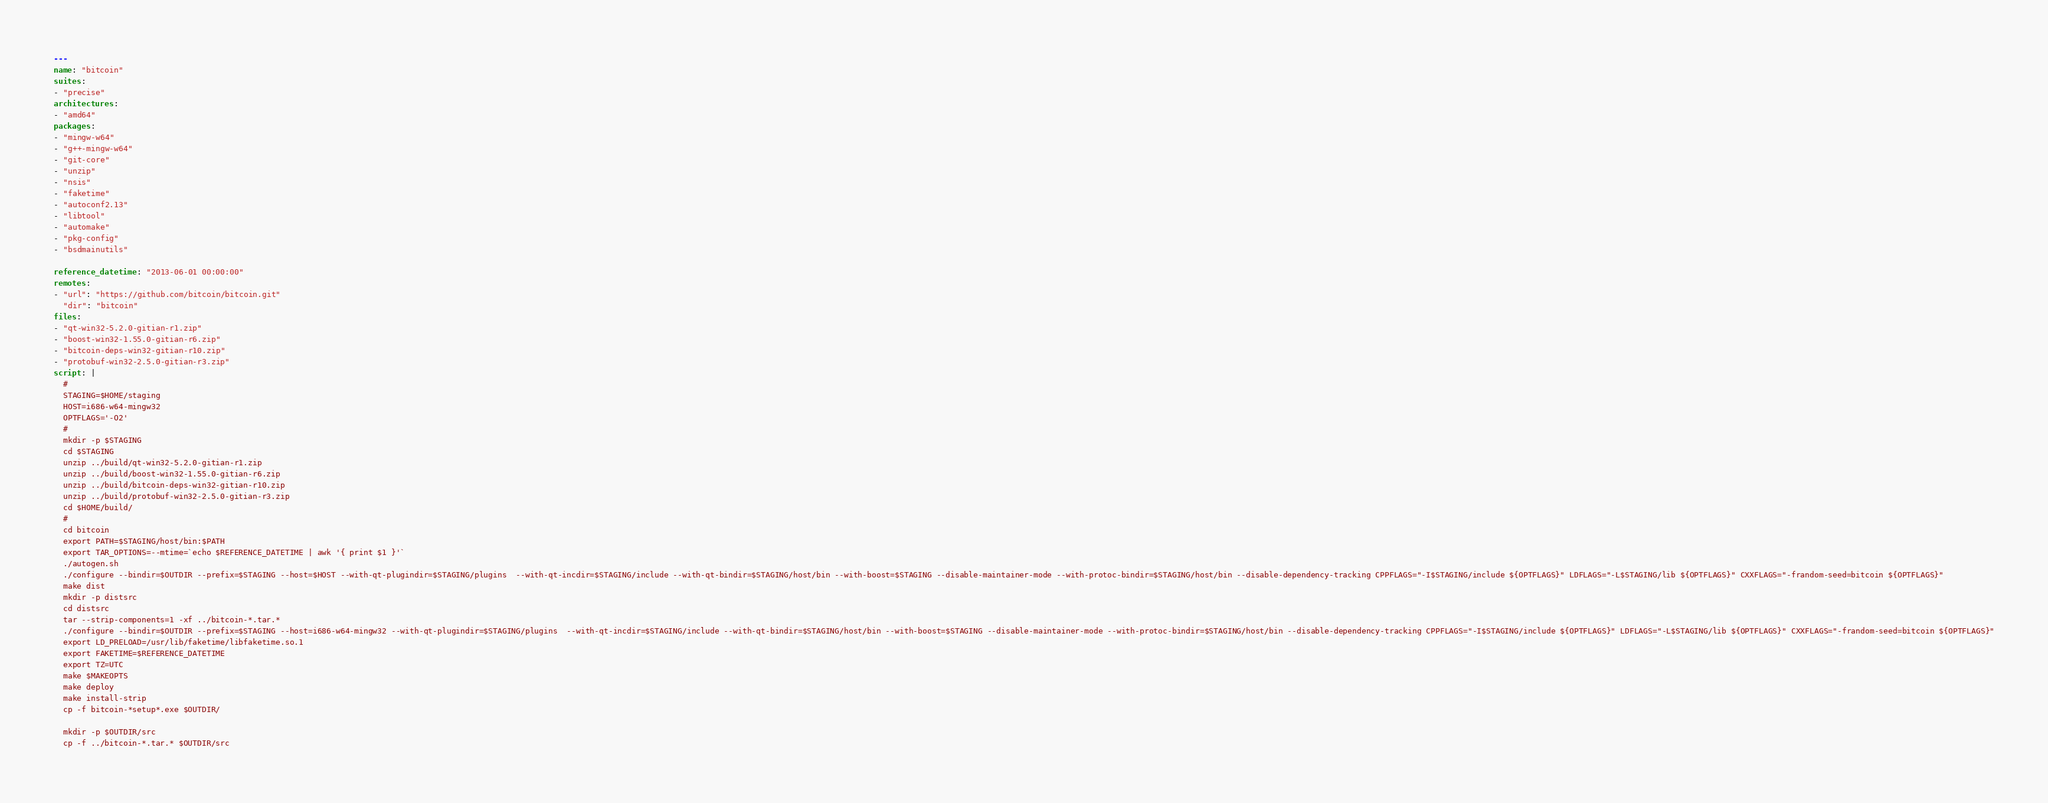Convert code to text. <code><loc_0><loc_0><loc_500><loc_500><_YAML_>---
name: "bitcoin"
suites:
- "precise"
architectures:
- "amd64"
packages:
- "mingw-w64"
- "g++-mingw-w64"
- "git-core"
- "unzip"
- "nsis"
- "faketime"
- "autoconf2.13"
- "libtool"
- "automake"
- "pkg-config"
- "bsdmainutils"

reference_datetime: "2013-06-01 00:00:00"
remotes:
- "url": "https://github.com/bitcoin/bitcoin.git"
  "dir": "bitcoin"
files:
- "qt-win32-5.2.0-gitian-r1.zip"
- "boost-win32-1.55.0-gitian-r6.zip"
- "bitcoin-deps-win32-gitian-r10.zip"
- "protobuf-win32-2.5.0-gitian-r3.zip"
script: |
  #
  STAGING=$HOME/staging
  HOST=i686-w64-mingw32
  OPTFLAGS='-O2'
  #
  mkdir -p $STAGING
  cd $STAGING
  unzip ../build/qt-win32-5.2.0-gitian-r1.zip
  unzip ../build/boost-win32-1.55.0-gitian-r6.zip
  unzip ../build/bitcoin-deps-win32-gitian-r10.zip
  unzip ../build/protobuf-win32-2.5.0-gitian-r3.zip
  cd $HOME/build/
  #
  cd bitcoin
  export PATH=$STAGING/host/bin:$PATH
  export TAR_OPTIONS=--mtime=`echo $REFERENCE_DATETIME | awk '{ print $1 }'`
  ./autogen.sh
  ./configure --bindir=$OUTDIR --prefix=$STAGING --host=$HOST --with-qt-plugindir=$STAGING/plugins  --with-qt-incdir=$STAGING/include --with-qt-bindir=$STAGING/host/bin --with-boost=$STAGING --disable-maintainer-mode --with-protoc-bindir=$STAGING/host/bin --disable-dependency-tracking CPPFLAGS="-I$STAGING/include ${OPTFLAGS}" LDFLAGS="-L$STAGING/lib ${OPTFLAGS}" CXXFLAGS="-frandom-seed=bitcoin ${OPTFLAGS}"
  make dist
  mkdir -p distsrc
  cd distsrc
  tar --strip-components=1 -xf ../bitcoin-*.tar.*
  ./configure --bindir=$OUTDIR --prefix=$STAGING --host=i686-w64-mingw32 --with-qt-plugindir=$STAGING/plugins  --with-qt-incdir=$STAGING/include --with-qt-bindir=$STAGING/host/bin --with-boost=$STAGING --disable-maintainer-mode --with-protoc-bindir=$STAGING/host/bin --disable-dependency-tracking CPPFLAGS="-I$STAGING/include ${OPTFLAGS}" LDFLAGS="-L$STAGING/lib ${OPTFLAGS}" CXXFLAGS="-frandom-seed=bitcoin ${OPTFLAGS}"
  export LD_PRELOAD=/usr/lib/faketime/libfaketime.so.1
  export FAKETIME=$REFERENCE_DATETIME
  export TZ=UTC
  make $MAKEOPTS
  make deploy
  make install-strip
  cp -f bitcoin-*setup*.exe $OUTDIR/

  mkdir -p $OUTDIR/src
  cp -f ../bitcoin-*.tar.* $OUTDIR/src
</code> 